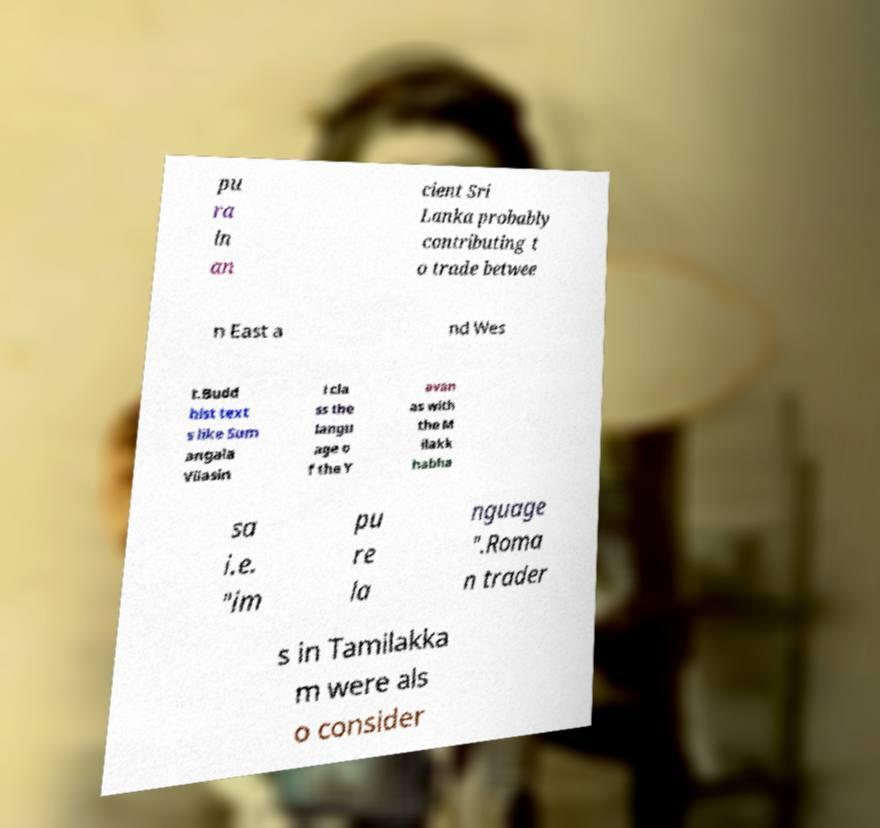I need the written content from this picture converted into text. Can you do that? pu ra in an cient Sri Lanka probably contributing t o trade betwee n East a nd Wes t.Budd hist text s like Sum angala Vilasin i cla ss the langu age o f the Y avan as with the M ilakk habha sa i.e. "im pu re la nguage ".Roma n trader s in Tamilakka m were als o consider 